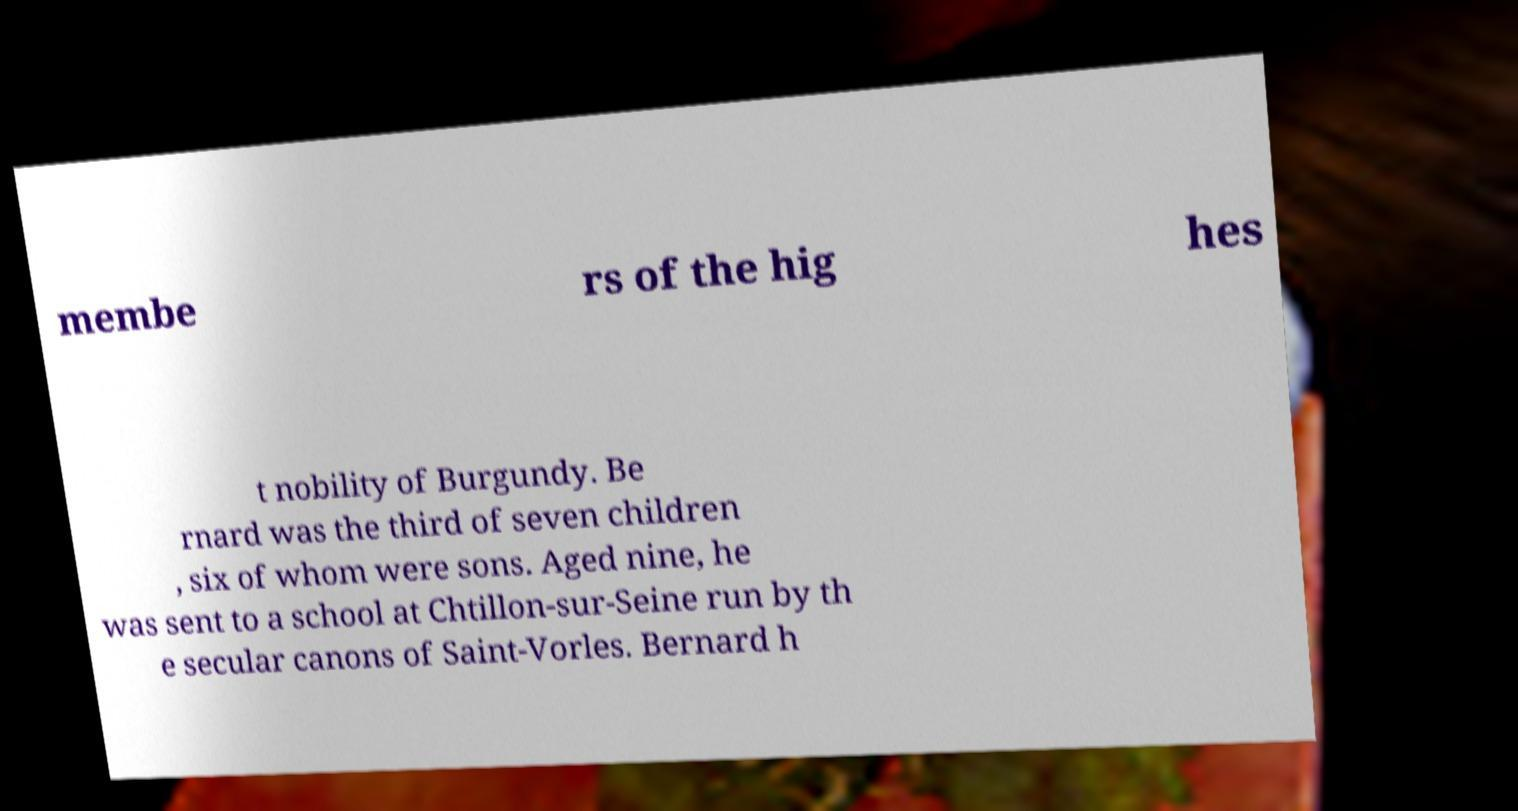Can you accurately transcribe the text from the provided image for me? membe rs of the hig hes t nobility of Burgundy. Be rnard was the third of seven children , six of whom were sons. Aged nine, he was sent to a school at Chtillon-sur-Seine run by th e secular canons of Saint-Vorles. Bernard h 